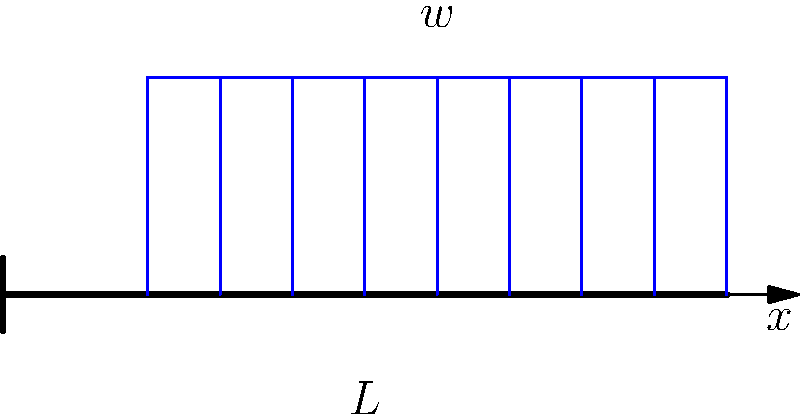For the cantilever beam shown above, with length $L$ and a uniformly distributed load $w$ applied over 80% of its length from the free end, sketch the shear force and bending moment diagrams. What is the maximum bending moment experienced by the beam? Let's approach this step-by-step:

1) First, we need to determine the total load on the beam:
   Total load $= 0.8L \times w$

2) The reaction force at the fixed end will be equal to the total load:
   $R = 0.8Lw$

3) The reaction moment at the fixed end can be calculated by taking moments about the fixed end:
   $M = 0.8Lw \times (0.8L/2 + 0.2L) = 0.8Lw \times 0.6L = 0.48L^2w$

4) For the shear force diagram:
   - From $x = 0$ to $x = 0.2L$, the shear force is constant and equal to $R = 0.8Lw$
   - From $x = 0.2L$ to $x = L$, the shear force decreases linearly to zero

5) For the bending moment diagram:
   - At $x = 0$ (fixed end), the bending moment is maximum and equal to $0.48L^2w$
   - It decreases quadratically to zero at $x = L$ (free end)

6) The maximum bending moment occurs at the fixed end and is equal to $0.48L^2w$
Answer: $0.48L^2w$ 